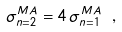Convert formula to latex. <formula><loc_0><loc_0><loc_500><loc_500>\sigma ^ { M A } _ { n = 2 } = 4 \, \sigma ^ { M A } _ { n = 1 } \ ,</formula> 